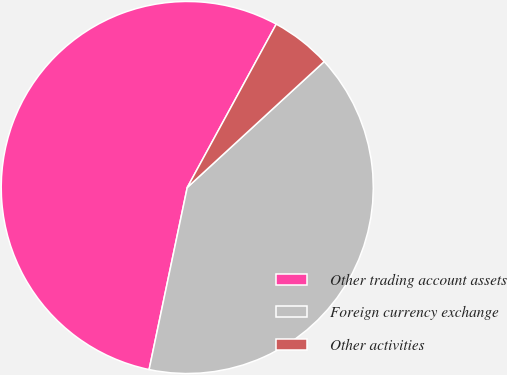Convert chart to OTSL. <chart><loc_0><loc_0><loc_500><loc_500><pie_chart><fcel>Other trading account assets<fcel>Foreign currency exchange<fcel>Other activities<nl><fcel>54.65%<fcel>40.12%<fcel>5.23%<nl></chart> 